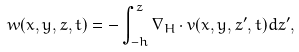<formula> <loc_0><loc_0><loc_500><loc_500>w ( x , y , z , t ) = - \int _ { - h } ^ { z } \nabla _ { H } \cdot v ( x , y , z ^ { \prime } , t ) d z ^ { \prime } ,</formula> 